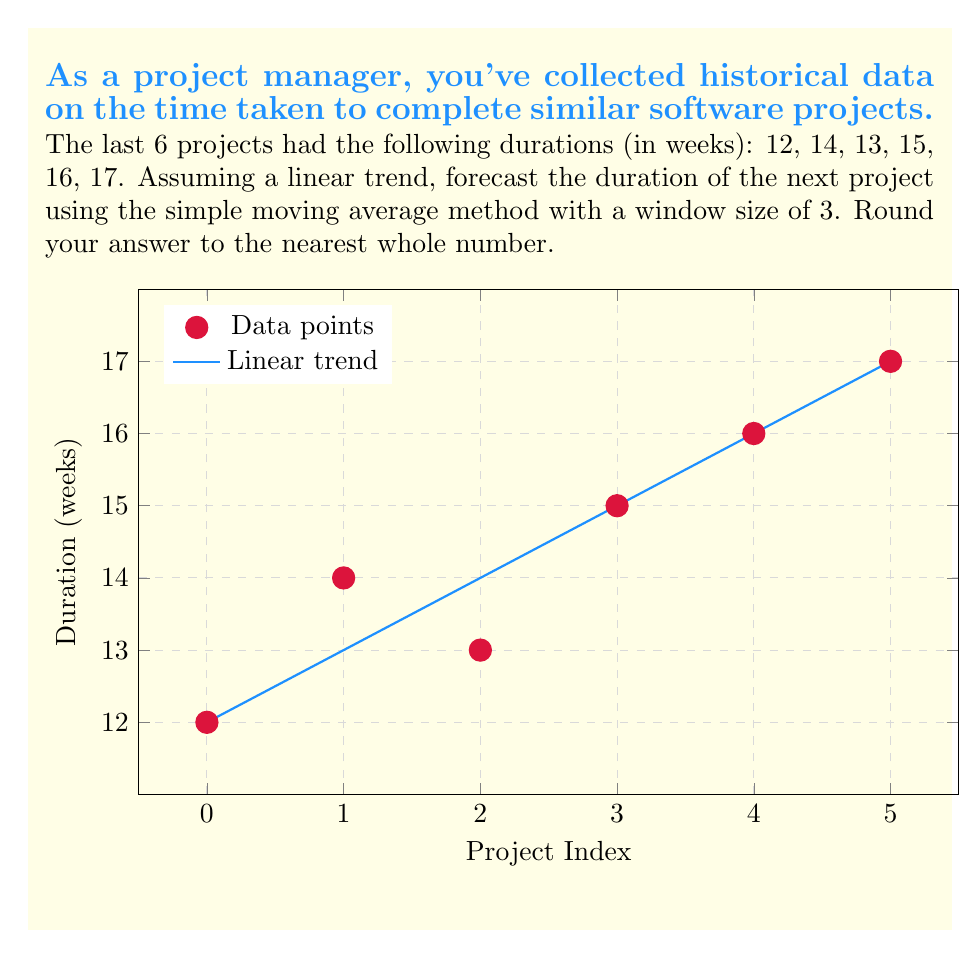Show me your answer to this math problem. To forecast the duration of the next project using the simple moving average method with a window size of 3, we'll follow these steps:

1) First, calculate the moving averages for the available data:
   
   MA1 = $\frac{12 + 14 + 13}{3} = 13$
   MA2 = $\frac{14 + 13 + 15}{3} = 14$
   MA3 = $\frac{13 + 15 + 16}{3} = 14.67$
   MA4 = $\frac{15 + 16 + 17}{3} = 16$

2) Now, we need to calculate the change between each moving average:
   
   Change1 = 14 - 13 = 1
   Change2 = 14.67 - 14 = 0.67
   Change3 = 16 - 14.67 = 1.33

3) Calculate the average change:
   
   Avg Change = $\frac{1 + 0.67 + 1.33}{3} = 1$

4) To forecast the next value, we add the average change to the last moving average:
   
   Forecast = 16 + 1 = 17

5) Rounding to the nearest whole number:
   
   17 (already a whole number)

Therefore, based on the historical data and using the simple moving average method, we forecast that the next project will take approximately 17 weeks.
Answer: 17 weeks 